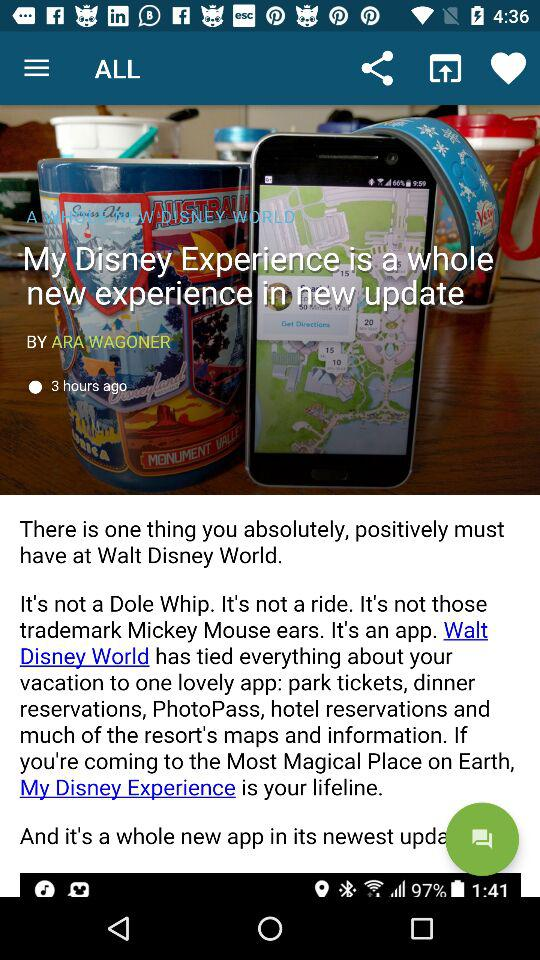What is the headline? The headline is "My Disney Experience is a whole new experience in new update". 